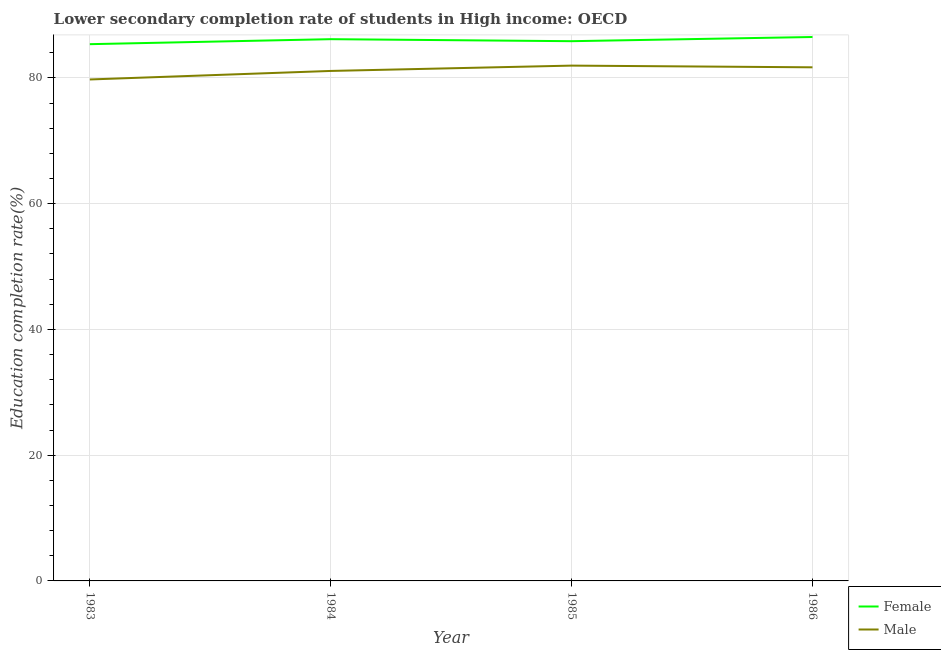How many different coloured lines are there?
Ensure brevity in your answer.  2. What is the education completion rate of male students in 1985?
Ensure brevity in your answer.  81.95. Across all years, what is the maximum education completion rate of male students?
Ensure brevity in your answer.  81.95. Across all years, what is the minimum education completion rate of male students?
Keep it short and to the point. 79.75. In which year was the education completion rate of female students minimum?
Your answer should be compact. 1983. What is the total education completion rate of female students in the graph?
Your response must be concise. 343.85. What is the difference between the education completion rate of female students in 1984 and that in 1986?
Give a very brief answer. -0.34. What is the difference between the education completion rate of male students in 1984 and the education completion rate of female students in 1985?
Give a very brief answer. -4.73. What is the average education completion rate of male students per year?
Make the answer very short. 81.12. In the year 1985, what is the difference between the education completion rate of female students and education completion rate of male students?
Ensure brevity in your answer.  3.88. In how many years, is the education completion rate of female students greater than 52 %?
Offer a very short reply. 4. What is the ratio of the education completion rate of male students in 1983 to that in 1984?
Offer a terse response. 0.98. What is the difference between the highest and the second highest education completion rate of male students?
Make the answer very short. 0.27. What is the difference between the highest and the lowest education completion rate of male students?
Provide a short and direct response. 2.2. In how many years, is the education completion rate of female students greater than the average education completion rate of female students taken over all years?
Give a very brief answer. 2. Is the education completion rate of male students strictly greater than the education completion rate of female students over the years?
Your response must be concise. No. Is the education completion rate of male students strictly less than the education completion rate of female students over the years?
Ensure brevity in your answer.  Yes. What is the difference between two consecutive major ticks on the Y-axis?
Offer a very short reply. 20. Are the values on the major ticks of Y-axis written in scientific E-notation?
Your response must be concise. No. Does the graph contain any zero values?
Offer a very short reply. No. Does the graph contain grids?
Offer a very short reply. Yes. Where does the legend appear in the graph?
Provide a short and direct response. Bottom right. How are the legend labels stacked?
Provide a succinct answer. Vertical. What is the title of the graph?
Your response must be concise. Lower secondary completion rate of students in High income: OECD. What is the label or title of the X-axis?
Give a very brief answer. Year. What is the label or title of the Y-axis?
Provide a short and direct response. Education completion rate(%). What is the Education completion rate(%) in Female in 1983?
Give a very brief answer. 85.36. What is the Education completion rate(%) of Male in 1983?
Your answer should be compact. 79.75. What is the Education completion rate(%) of Female in 1984?
Give a very brief answer. 86.16. What is the Education completion rate(%) in Male in 1984?
Offer a very short reply. 81.1. What is the Education completion rate(%) of Female in 1985?
Make the answer very short. 85.83. What is the Education completion rate(%) in Male in 1985?
Your answer should be compact. 81.95. What is the Education completion rate(%) in Female in 1986?
Make the answer very short. 86.5. What is the Education completion rate(%) of Male in 1986?
Your response must be concise. 81.68. Across all years, what is the maximum Education completion rate(%) in Female?
Your answer should be very brief. 86.5. Across all years, what is the maximum Education completion rate(%) in Male?
Give a very brief answer. 81.95. Across all years, what is the minimum Education completion rate(%) in Female?
Offer a very short reply. 85.36. Across all years, what is the minimum Education completion rate(%) in Male?
Offer a very short reply. 79.75. What is the total Education completion rate(%) in Female in the graph?
Offer a terse response. 343.85. What is the total Education completion rate(%) of Male in the graph?
Keep it short and to the point. 324.48. What is the difference between the Education completion rate(%) of Female in 1983 and that in 1984?
Keep it short and to the point. -0.8. What is the difference between the Education completion rate(%) of Male in 1983 and that in 1984?
Give a very brief answer. -1.36. What is the difference between the Education completion rate(%) in Female in 1983 and that in 1985?
Your response must be concise. -0.48. What is the difference between the Education completion rate(%) of Male in 1983 and that in 1985?
Offer a terse response. -2.2. What is the difference between the Education completion rate(%) in Female in 1983 and that in 1986?
Your answer should be very brief. -1.14. What is the difference between the Education completion rate(%) in Male in 1983 and that in 1986?
Your answer should be compact. -1.93. What is the difference between the Education completion rate(%) in Female in 1984 and that in 1985?
Provide a succinct answer. 0.32. What is the difference between the Education completion rate(%) of Male in 1984 and that in 1985?
Provide a short and direct response. -0.85. What is the difference between the Education completion rate(%) in Female in 1984 and that in 1986?
Offer a terse response. -0.34. What is the difference between the Education completion rate(%) of Male in 1984 and that in 1986?
Keep it short and to the point. -0.58. What is the difference between the Education completion rate(%) of Female in 1985 and that in 1986?
Provide a short and direct response. -0.67. What is the difference between the Education completion rate(%) in Male in 1985 and that in 1986?
Your answer should be compact. 0.27. What is the difference between the Education completion rate(%) of Female in 1983 and the Education completion rate(%) of Male in 1984?
Give a very brief answer. 4.25. What is the difference between the Education completion rate(%) in Female in 1983 and the Education completion rate(%) in Male in 1985?
Provide a succinct answer. 3.41. What is the difference between the Education completion rate(%) of Female in 1983 and the Education completion rate(%) of Male in 1986?
Your answer should be very brief. 3.68. What is the difference between the Education completion rate(%) in Female in 1984 and the Education completion rate(%) in Male in 1985?
Provide a succinct answer. 4.21. What is the difference between the Education completion rate(%) in Female in 1984 and the Education completion rate(%) in Male in 1986?
Your answer should be very brief. 4.48. What is the difference between the Education completion rate(%) of Female in 1985 and the Education completion rate(%) of Male in 1986?
Your response must be concise. 4.15. What is the average Education completion rate(%) of Female per year?
Your answer should be very brief. 85.96. What is the average Education completion rate(%) in Male per year?
Provide a short and direct response. 81.12. In the year 1983, what is the difference between the Education completion rate(%) in Female and Education completion rate(%) in Male?
Offer a very short reply. 5.61. In the year 1984, what is the difference between the Education completion rate(%) of Female and Education completion rate(%) of Male?
Make the answer very short. 5.05. In the year 1985, what is the difference between the Education completion rate(%) in Female and Education completion rate(%) in Male?
Keep it short and to the point. 3.88. In the year 1986, what is the difference between the Education completion rate(%) in Female and Education completion rate(%) in Male?
Offer a very short reply. 4.82. What is the ratio of the Education completion rate(%) in Male in 1983 to that in 1984?
Your answer should be compact. 0.98. What is the ratio of the Education completion rate(%) of Male in 1983 to that in 1985?
Make the answer very short. 0.97. What is the ratio of the Education completion rate(%) of Female in 1983 to that in 1986?
Your response must be concise. 0.99. What is the ratio of the Education completion rate(%) of Male in 1983 to that in 1986?
Provide a succinct answer. 0.98. What is the ratio of the Education completion rate(%) in Female in 1984 to that in 1985?
Your answer should be very brief. 1. What is the ratio of the Education completion rate(%) in Female in 1984 to that in 1986?
Your answer should be very brief. 1. What is the difference between the highest and the second highest Education completion rate(%) in Female?
Keep it short and to the point. 0.34. What is the difference between the highest and the second highest Education completion rate(%) in Male?
Offer a terse response. 0.27. What is the difference between the highest and the lowest Education completion rate(%) of Female?
Your answer should be very brief. 1.14. What is the difference between the highest and the lowest Education completion rate(%) of Male?
Your answer should be compact. 2.2. 